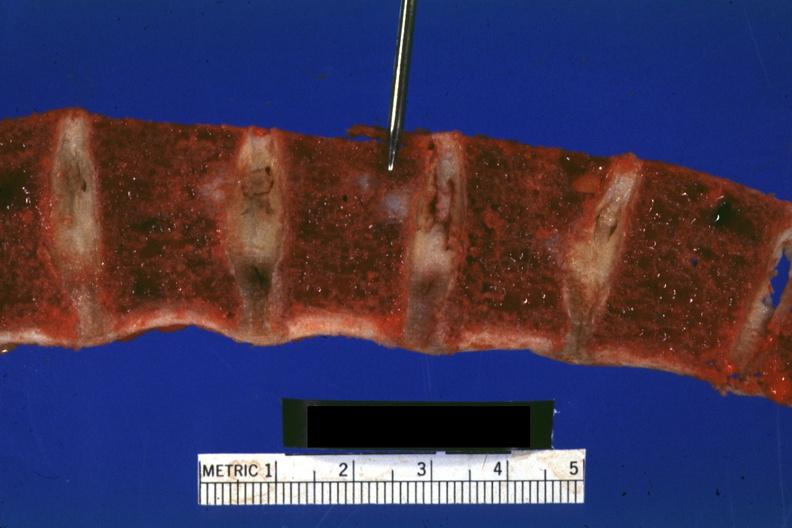s joints present?
Answer the question using a single word or phrase. Yes 